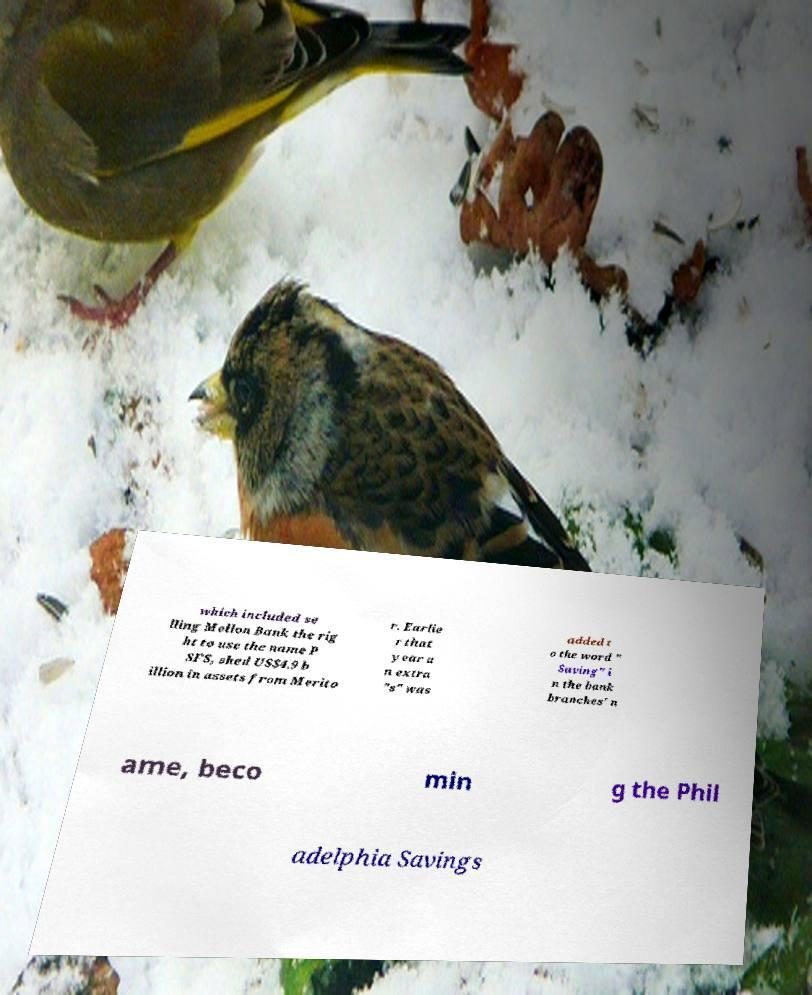Can you read and provide the text displayed in the image?This photo seems to have some interesting text. Can you extract and type it out for me? which included se lling Mellon Bank the rig ht to use the name P SFS, shed US$4.9 b illion in assets from Merito r. Earlie r that year a n extra "s" was added t o the word " Saving" i n the bank branches' n ame, beco min g the Phil adelphia Savings 